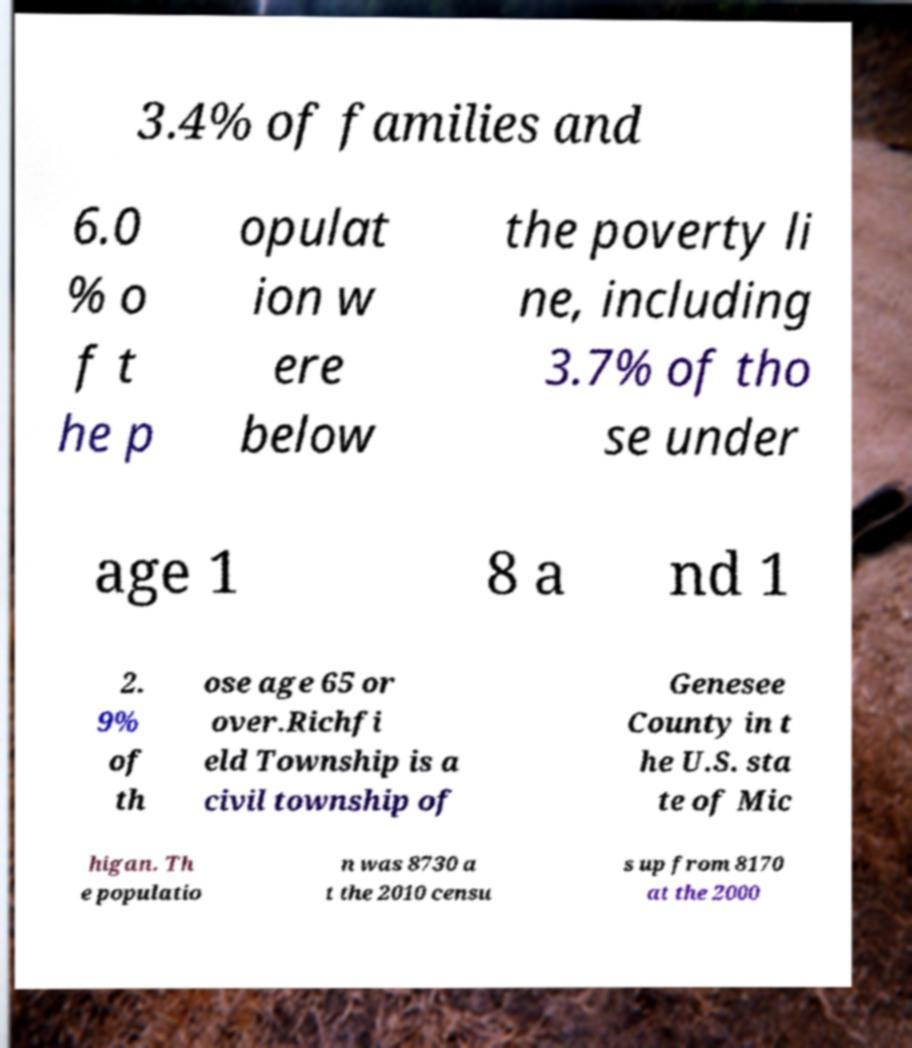Could you extract and type out the text from this image? 3.4% of families and 6.0 % o f t he p opulat ion w ere below the poverty li ne, including 3.7% of tho se under age 1 8 a nd 1 2. 9% of th ose age 65 or over.Richfi eld Township is a civil township of Genesee County in t he U.S. sta te of Mic higan. Th e populatio n was 8730 a t the 2010 censu s up from 8170 at the 2000 